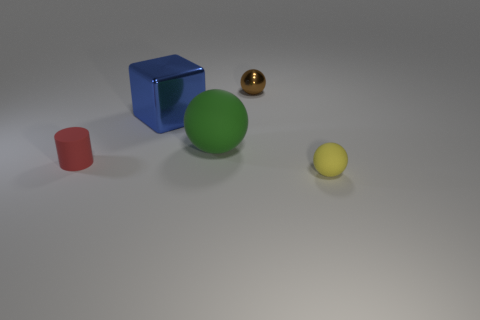Subtract all small balls. How many balls are left? 1 Subtract all cubes. How many objects are left? 4 Subtract 2 spheres. How many spheres are left? 1 Subtract all yellow spheres. How many spheres are left? 2 Subtract all red spheres. How many purple cubes are left? 0 Subtract all small cylinders. Subtract all metallic balls. How many objects are left? 3 Add 4 big blue objects. How many big blue objects are left? 5 Add 4 cyan metal cylinders. How many cyan metal cylinders exist? 4 Add 3 balls. How many objects exist? 8 Subtract 0 blue cylinders. How many objects are left? 5 